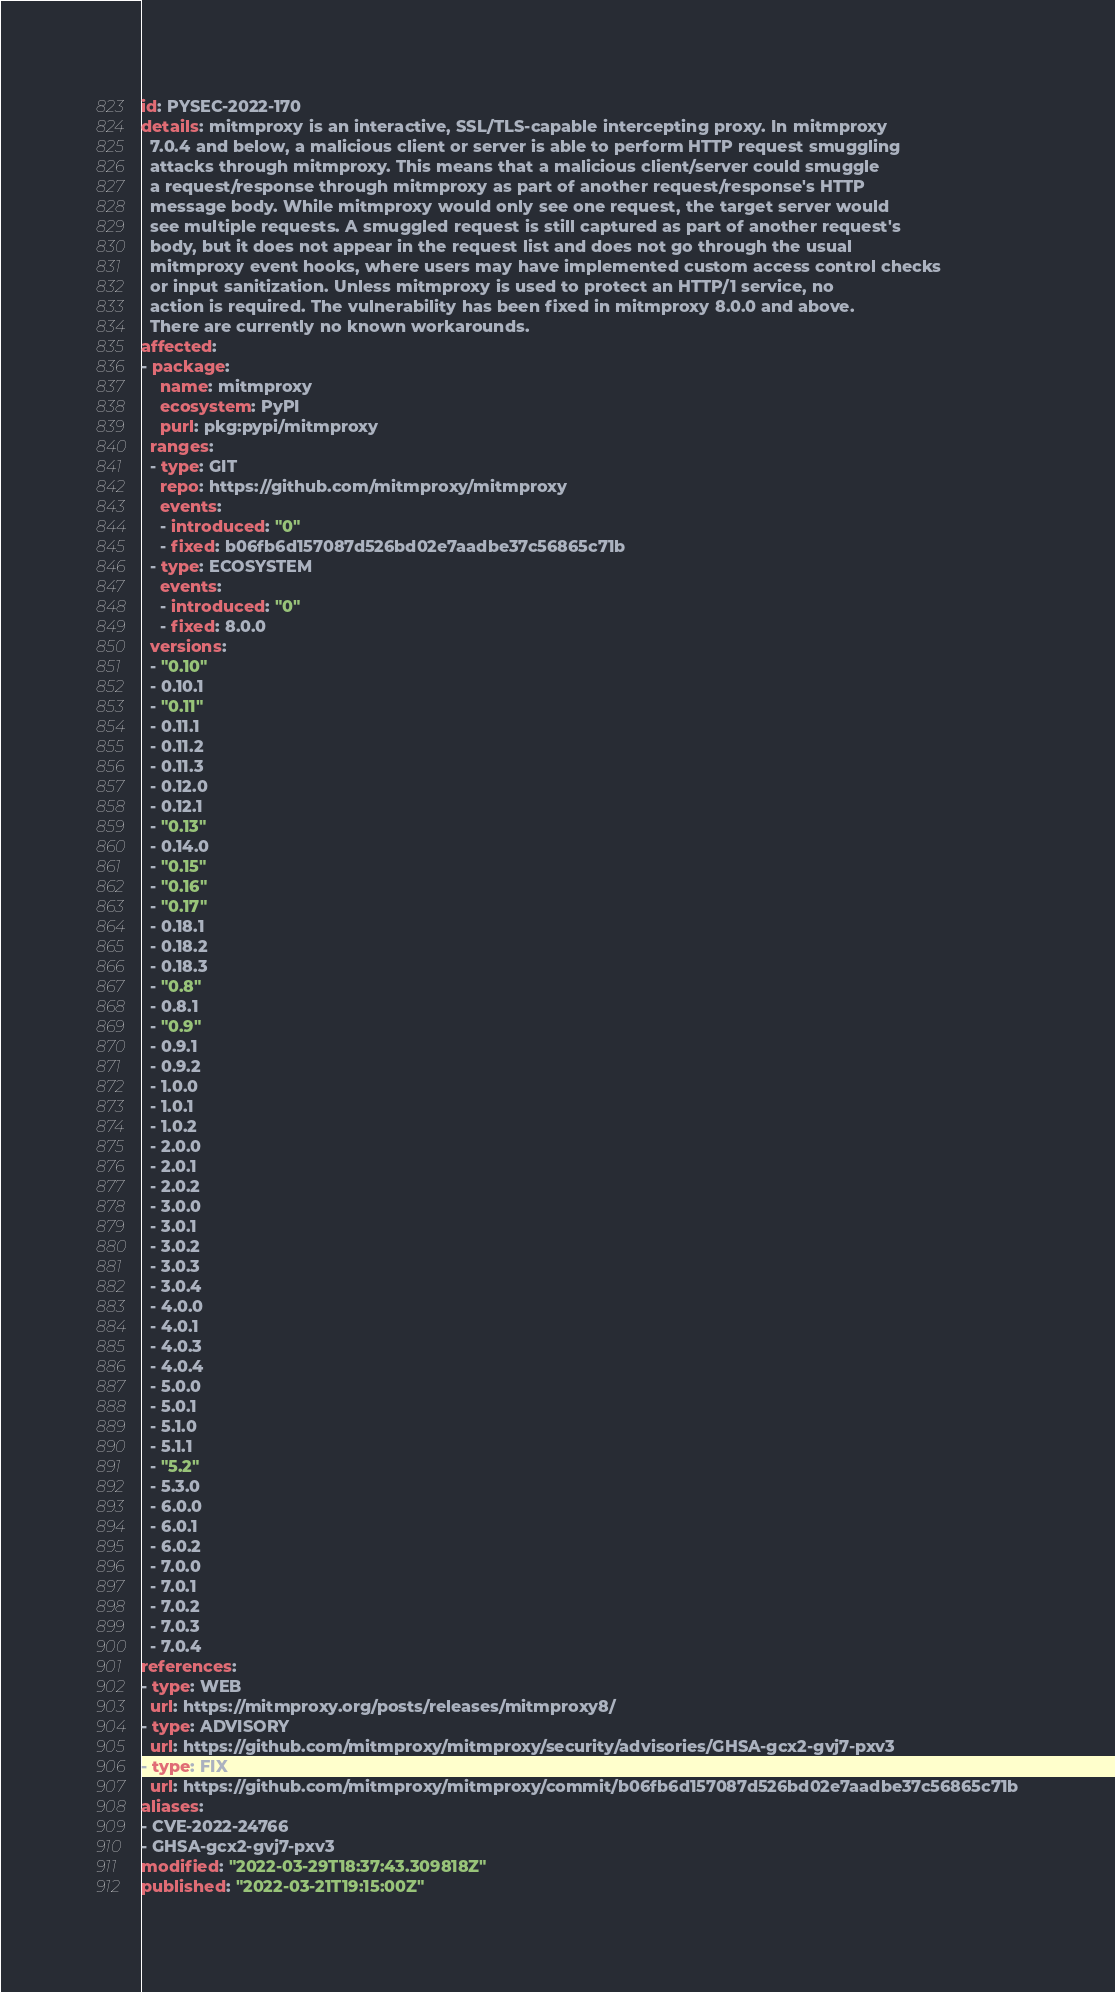<code> <loc_0><loc_0><loc_500><loc_500><_YAML_>id: PYSEC-2022-170
details: mitmproxy is an interactive, SSL/TLS-capable intercepting proxy. In mitmproxy
  7.0.4 and below, a malicious client or server is able to perform HTTP request smuggling
  attacks through mitmproxy. This means that a malicious client/server could smuggle
  a request/response through mitmproxy as part of another request/response's HTTP
  message body. While mitmproxy would only see one request, the target server would
  see multiple requests. A smuggled request is still captured as part of another request's
  body, but it does not appear in the request list and does not go through the usual
  mitmproxy event hooks, where users may have implemented custom access control checks
  or input sanitization. Unless mitmproxy is used to protect an HTTP/1 service, no
  action is required. The vulnerability has been fixed in mitmproxy 8.0.0 and above.
  There are currently no known workarounds.
affected:
- package:
    name: mitmproxy
    ecosystem: PyPI
    purl: pkg:pypi/mitmproxy
  ranges:
  - type: GIT
    repo: https://github.com/mitmproxy/mitmproxy
    events:
    - introduced: "0"
    - fixed: b06fb6d157087d526bd02e7aadbe37c56865c71b
  - type: ECOSYSTEM
    events:
    - introduced: "0"
    - fixed: 8.0.0
  versions:
  - "0.10"
  - 0.10.1
  - "0.11"
  - 0.11.1
  - 0.11.2
  - 0.11.3
  - 0.12.0
  - 0.12.1
  - "0.13"
  - 0.14.0
  - "0.15"
  - "0.16"
  - "0.17"
  - 0.18.1
  - 0.18.2
  - 0.18.3
  - "0.8"
  - 0.8.1
  - "0.9"
  - 0.9.1
  - 0.9.2
  - 1.0.0
  - 1.0.1
  - 1.0.2
  - 2.0.0
  - 2.0.1
  - 2.0.2
  - 3.0.0
  - 3.0.1
  - 3.0.2
  - 3.0.3
  - 3.0.4
  - 4.0.0
  - 4.0.1
  - 4.0.3
  - 4.0.4
  - 5.0.0
  - 5.0.1
  - 5.1.0
  - 5.1.1
  - "5.2"
  - 5.3.0
  - 6.0.0
  - 6.0.1
  - 6.0.2
  - 7.0.0
  - 7.0.1
  - 7.0.2
  - 7.0.3
  - 7.0.4
references:
- type: WEB
  url: https://mitmproxy.org/posts/releases/mitmproxy8/
- type: ADVISORY
  url: https://github.com/mitmproxy/mitmproxy/security/advisories/GHSA-gcx2-gvj7-pxv3
- type: FIX
  url: https://github.com/mitmproxy/mitmproxy/commit/b06fb6d157087d526bd02e7aadbe37c56865c71b
aliases:
- CVE-2022-24766
- GHSA-gcx2-gvj7-pxv3
modified: "2022-03-29T18:37:43.309818Z"
published: "2022-03-21T19:15:00Z"
</code> 